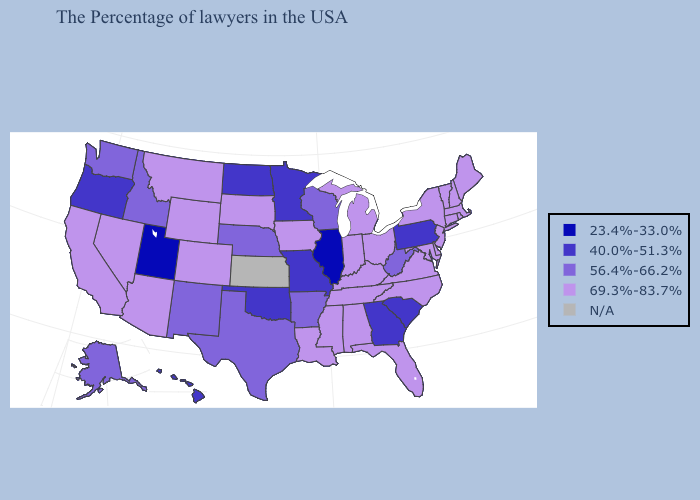What is the value of New York?
Concise answer only. 69.3%-83.7%. What is the lowest value in the Northeast?
Give a very brief answer. 40.0%-51.3%. Name the states that have a value in the range 69.3%-83.7%?
Short answer required. Maine, Massachusetts, Rhode Island, New Hampshire, Vermont, Connecticut, New York, New Jersey, Delaware, Maryland, Virginia, North Carolina, Ohio, Florida, Michigan, Kentucky, Indiana, Alabama, Tennessee, Mississippi, Louisiana, Iowa, South Dakota, Wyoming, Colorado, Montana, Arizona, Nevada, California. Does Colorado have the lowest value in the West?
Keep it brief. No. What is the value of Rhode Island?
Concise answer only. 69.3%-83.7%. Which states hav the highest value in the West?
Short answer required. Wyoming, Colorado, Montana, Arizona, Nevada, California. Does the first symbol in the legend represent the smallest category?
Short answer required. Yes. Which states have the highest value in the USA?
Short answer required. Maine, Massachusetts, Rhode Island, New Hampshire, Vermont, Connecticut, New York, New Jersey, Delaware, Maryland, Virginia, North Carolina, Ohio, Florida, Michigan, Kentucky, Indiana, Alabama, Tennessee, Mississippi, Louisiana, Iowa, South Dakota, Wyoming, Colorado, Montana, Arizona, Nevada, California. What is the lowest value in the MidWest?
Answer briefly. 23.4%-33.0%. Name the states that have a value in the range 69.3%-83.7%?
Concise answer only. Maine, Massachusetts, Rhode Island, New Hampshire, Vermont, Connecticut, New York, New Jersey, Delaware, Maryland, Virginia, North Carolina, Ohio, Florida, Michigan, Kentucky, Indiana, Alabama, Tennessee, Mississippi, Louisiana, Iowa, South Dakota, Wyoming, Colorado, Montana, Arizona, Nevada, California. Does Kentucky have the highest value in the South?
Give a very brief answer. Yes. What is the value of Maryland?
Give a very brief answer. 69.3%-83.7%. Among the states that border New York , does Connecticut have the highest value?
Write a very short answer. Yes. Does Oregon have the highest value in the USA?
Write a very short answer. No. 